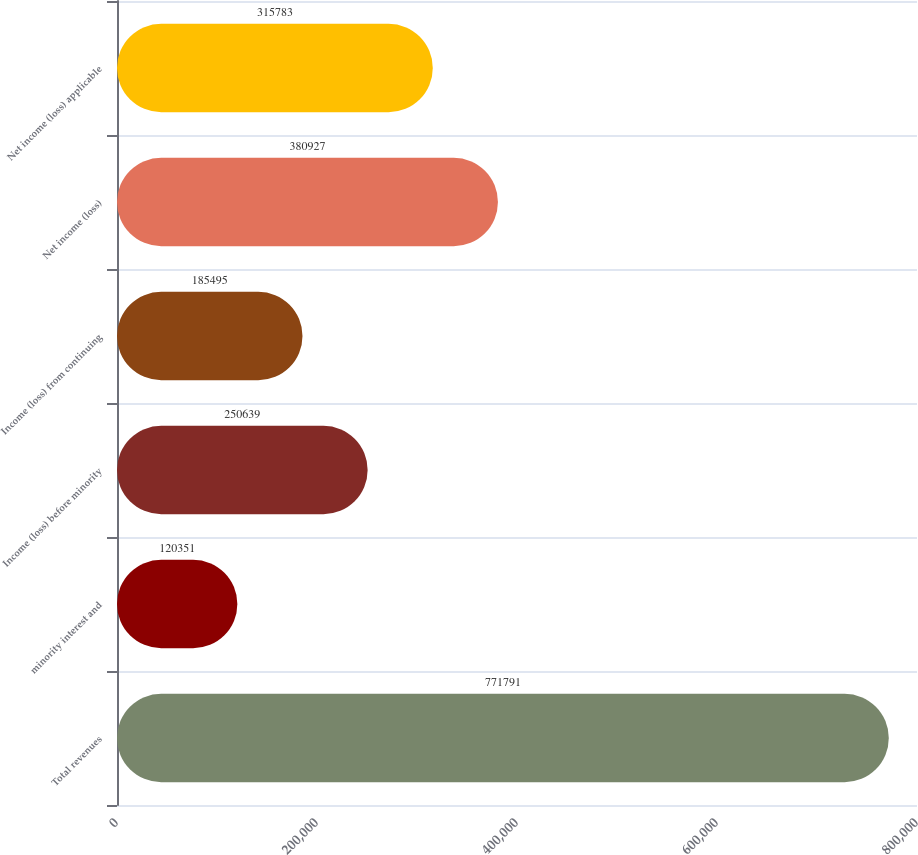<chart> <loc_0><loc_0><loc_500><loc_500><bar_chart><fcel>Total revenues<fcel>minority interest and<fcel>Income (loss) before minority<fcel>Income (loss) from continuing<fcel>Net income (loss)<fcel>Net income (loss) applicable<nl><fcel>771791<fcel>120351<fcel>250639<fcel>185495<fcel>380927<fcel>315783<nl></chart> 